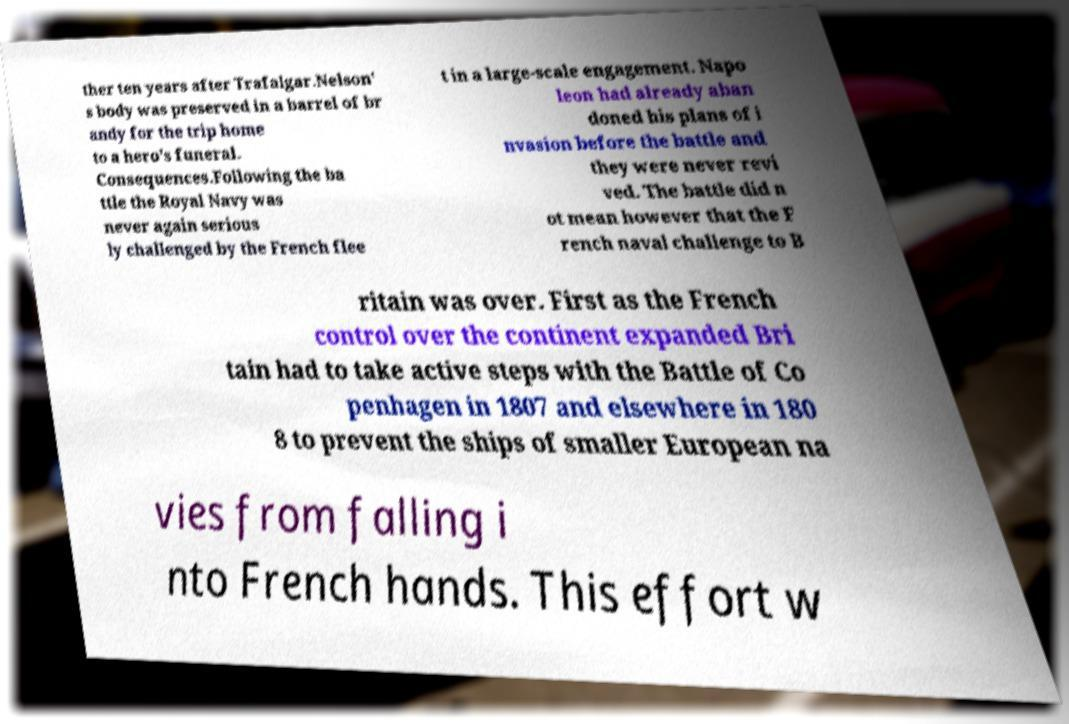Please read and relay the text visible in this image. What does it say? ther ten years after Trafalgar.Nelson' s body was preserved in a barrel of br andy for the trip home to a hero's funeral. Consequences.Following the ba ttle the Royal Navy was never again serious ly challenged by the French flee t in a large-scale engagement. Napo leon had already aban doned his plans of i nvasion before the battle and they were never revi ved. The battle did n ot mean however that the F rench naval challenge to B ritain was over. First as the French control over the continent expanded Bri tain had to take active steps with the Battle of Co penhagen in 1807 and elsewhere in 180 8 to prevent the ships of smaller European na vies from falling i nto French hands. This effort w 